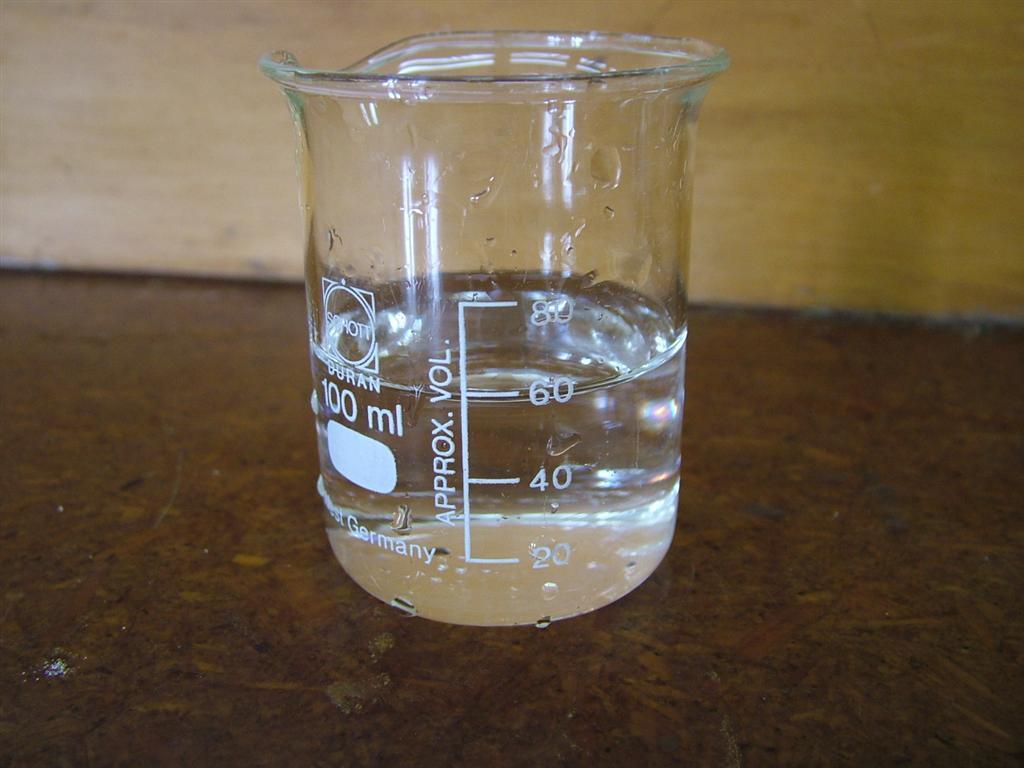How many ml of liquid are in the beaker?
Your answer should be very brief. 60. Where was this measuring cup made?
Your response must be concise. Germany. 